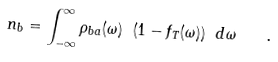<formula> <loc_0><loc_0><loc_500><loc_500>n _ { b } = \int _ { - \infty } ^ { \infty } \rho _ { b a } ( \omega ) \ ( 1 - f _ { T } ( \omega ) ) \ d \omega \quad .</formula> 